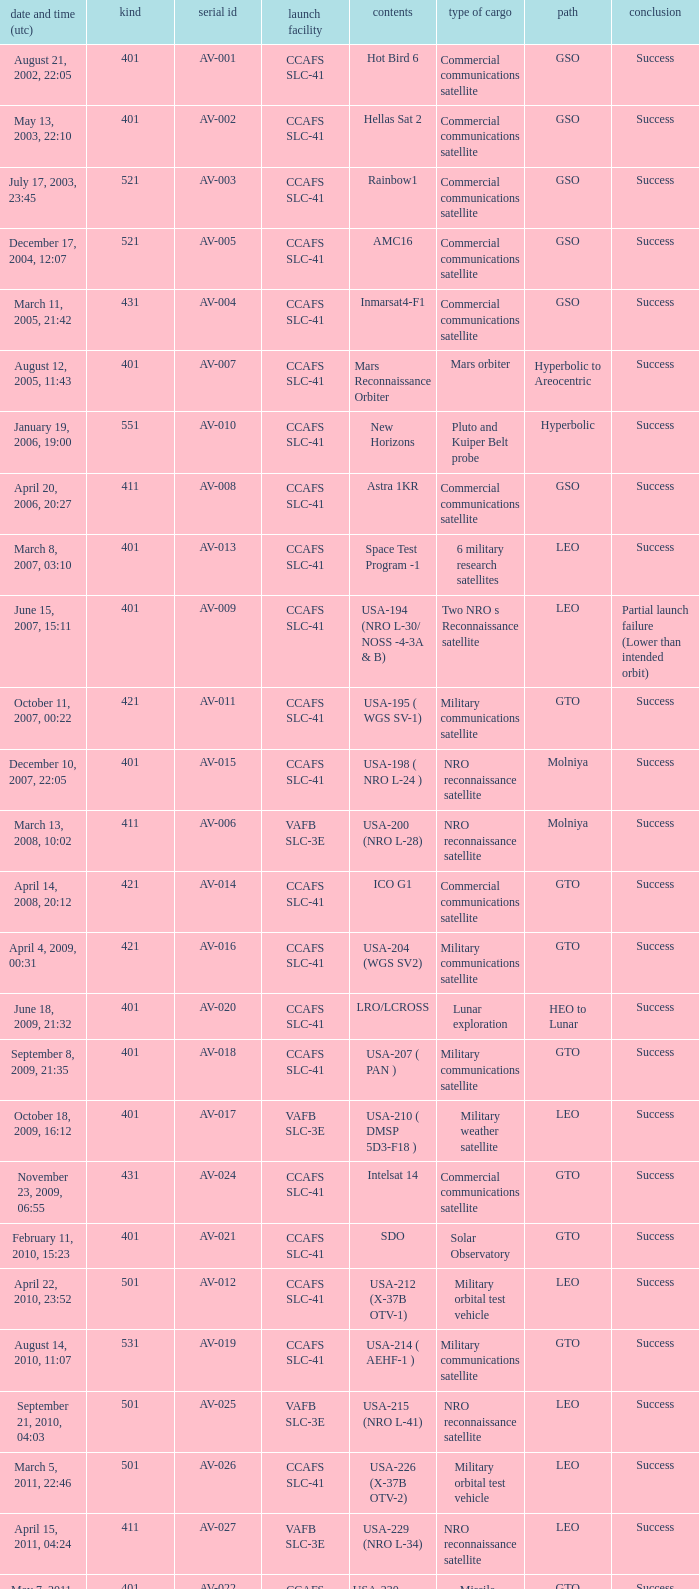For the payload of Van Allen Belts Exploration what's the serial number? AV-032. 